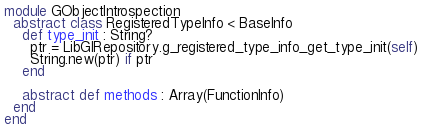<code> <loc_0><loc_0><loc_500><loc_500><_Crystal_>module GObjectIntrospection
  abstract class RegisteredTypeInfo < BaseInfo
    def type_init : String?
      ptr = LibGIRepository.g_registered_type_info_get_type_init(self)
      String.new(ptr) if ptr
    end

    abstract def methods : Array(FunctionInfo)
  end
end
</code> 